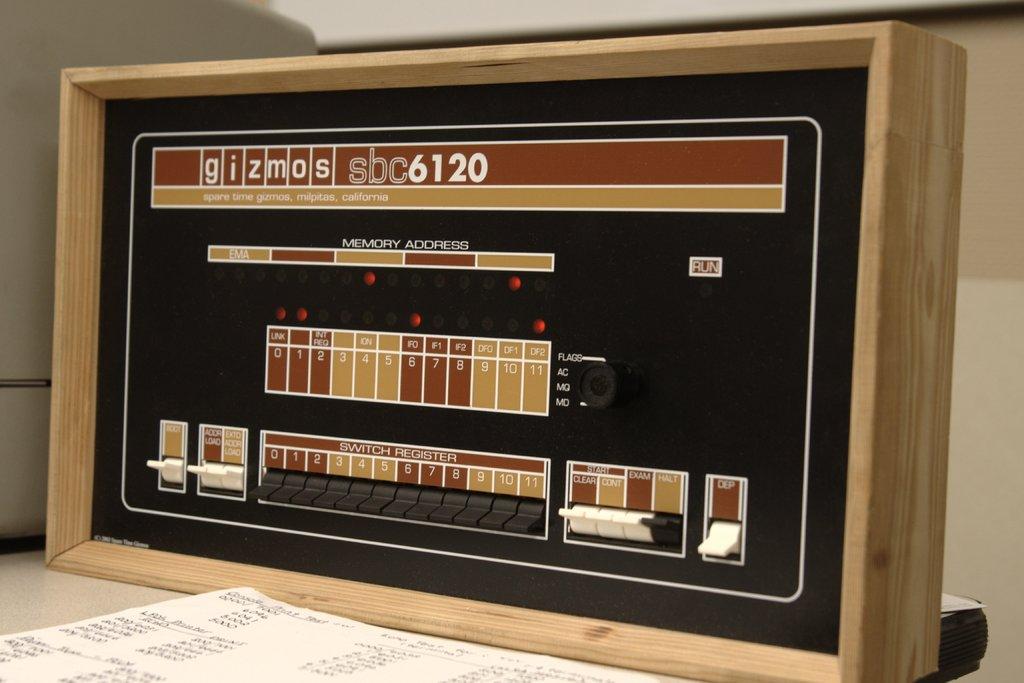What is the model of this device?
Provide a succinct answer. Sbc6120. 